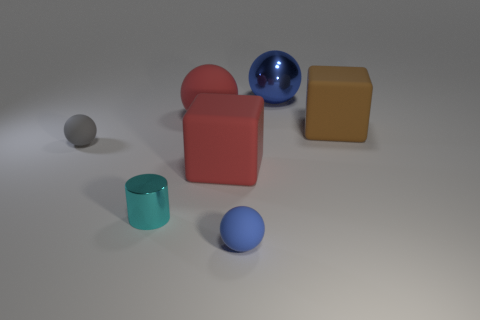Subtract all gray spheres. How many spheres are left? 3 Subtract all big blue balls. How many balls are left? 3 Add 2 small shiny cylinders. How many objects exist? 9 Subtract all yellow balls. Subtract all gray blocks. How many balls are left? 4 Subtract all balls. How many objects are left? 3 Subtract 1 gray balls. How many objects are left? 6 Subtract all cyan cylinders. Subtract all big rubber objects. How many objects are left? 3 Add 3 big brown cubes. How many big brown cubes are left? 4 Add 7 big brown cubes. How many big brown cubes exist? 8 